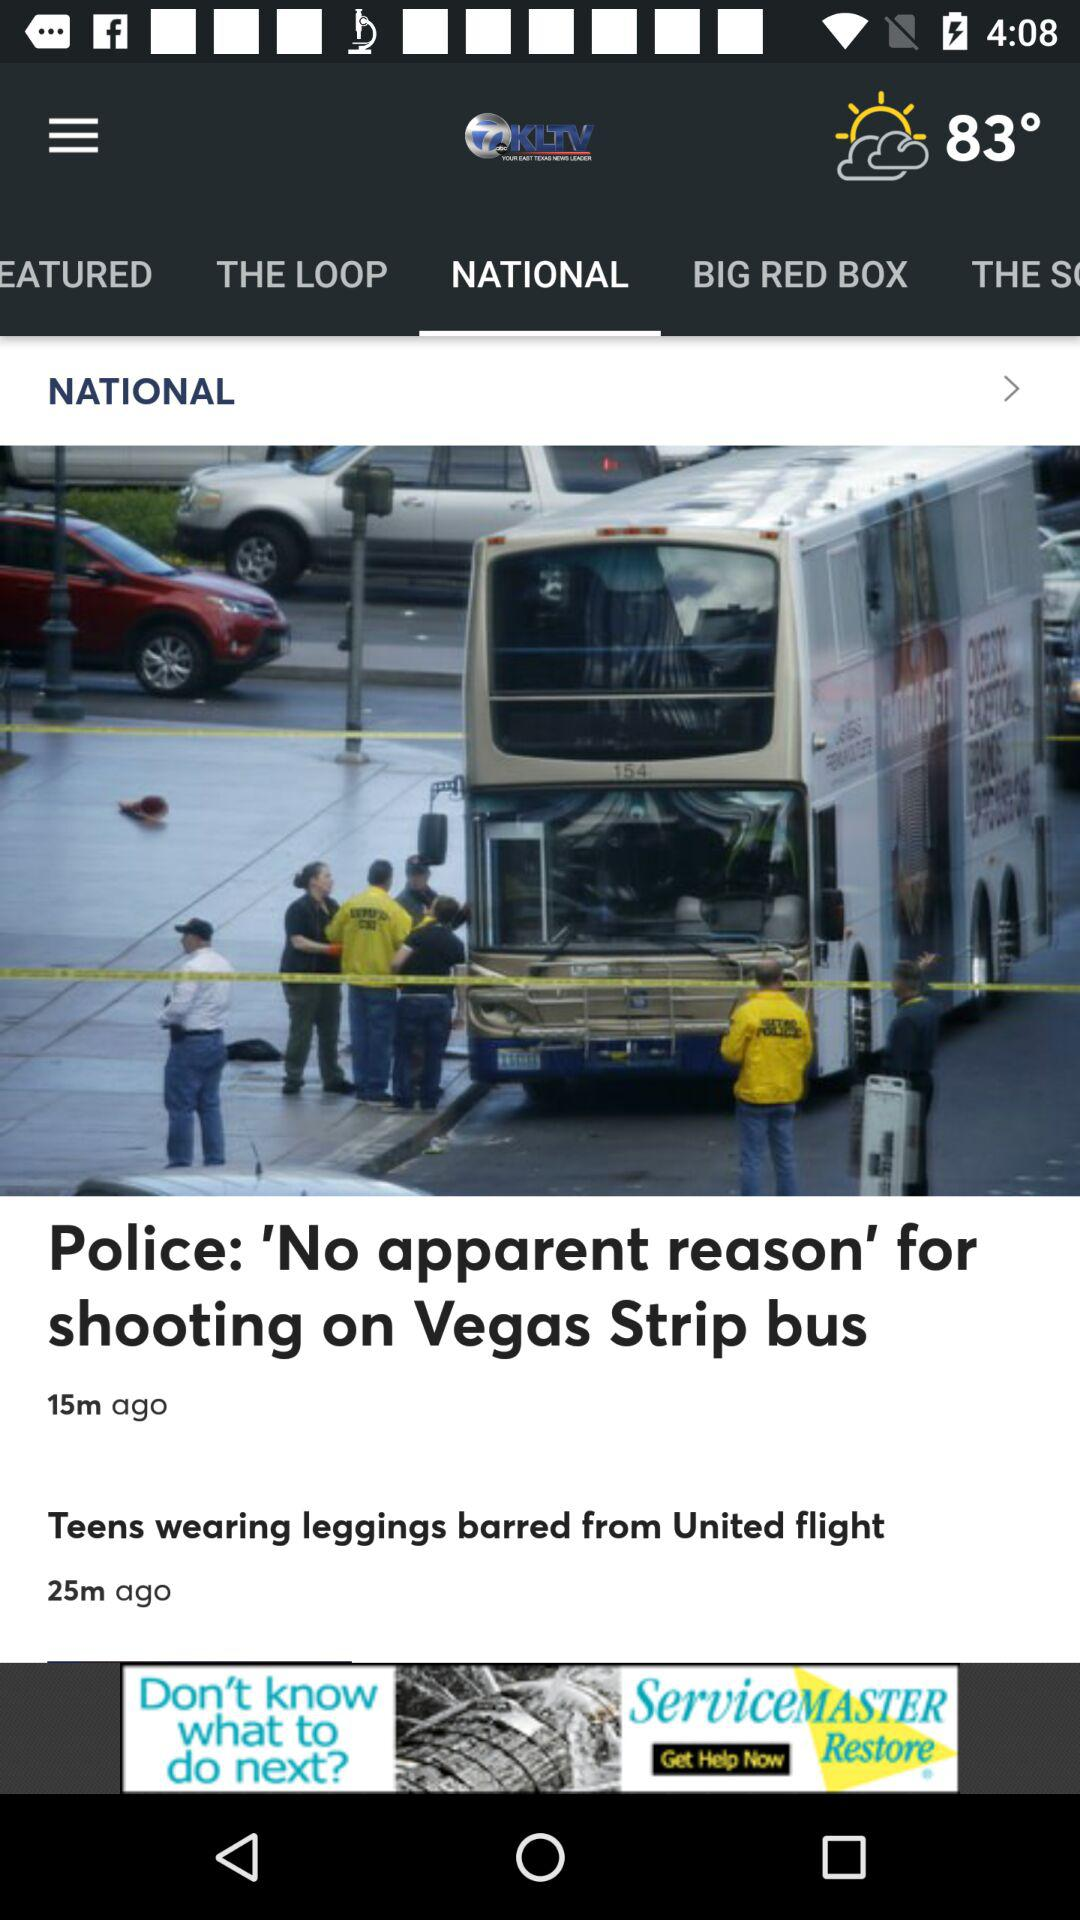What is the temperature? The temperature is 83°. 